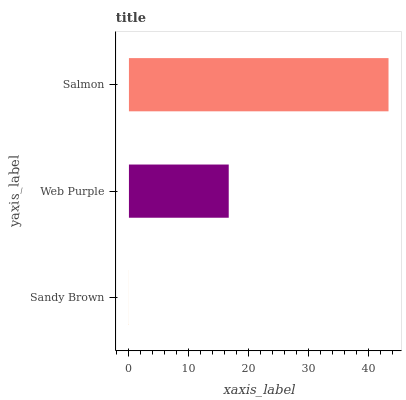Is Sandy Brown the minimum?
Answer yes or no. Yes. Is Salmon the maximum?
Answer yes or no. Yes. Is Web Purple the minimum?
Answer yes or no. No. Is Web Purple the maximum?
Answer yes or no. No. Is Web Purple greater than Sandy Brown?
Answer yes or no. Yes. Is Sandy Brown less than Web Purple?
Answer yes or no. Yes. Is Sandy Brown greater than Web Purple?
Answer yes or no. No. Is Web Purple less than Sandy Brown?
Answer yes or no. No. Is Web Purple the high median?
Answer yes or no. Yes. Is Web Purple the low median?
Answer yes or no. Yes. Is Sandy Brown the high median?
Answer yes or no. No. Is Salmon the low median?
Answer yes or no. No. 